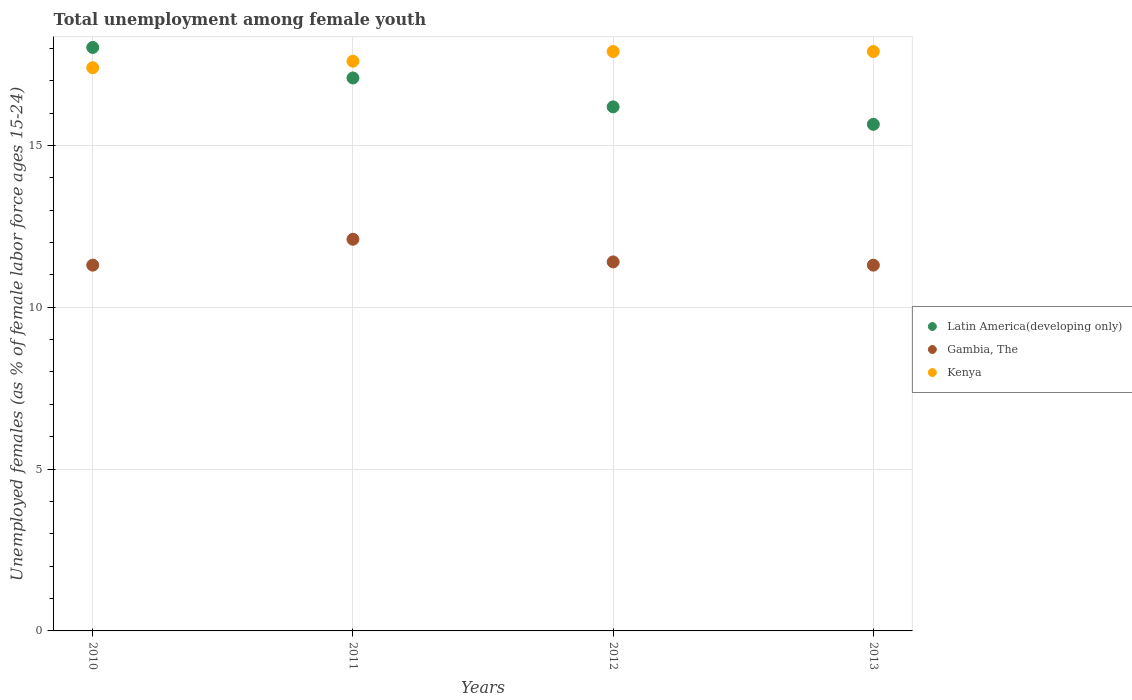Is the number of dotlines equal to the number of legend labels?
Provide a short and direct response. Yes. What is the percentage of unemployed females in in Gambia, The in 2010?
Your answer should be very brief. 11.3. Across all years, what is the maximum percentage of unemployed females in in Kenya?
Your answer should be compact. 17.9. Across all years, what is the minimum percentage of unemployed females in in Gambia, The?
Make the answer very short. 11.3. In which year was the percentage of unemployed females in in Gambia, The maximum?
Keep it short and to the point. 2011. What is the total percentage of unemployed females in in Kenya in the graph?
Give a very brief answer. 70.8. What is the difference between the percentage of unemployed females in in Gambia, The in 2010 and that in 2012?
Offer a terse response. -0.1. What is the difference between the percentage of unemployed females in in Gambia, The in 2013 and the percentage of unemployed females in in Latin America(developing only) in 2012?
Provide a short and direct response. -4.89. What is the average percentage of unemployed females in in Gambia, The per year?
Provide a short and direct response. 11.53. In the year 2010, what is the difference between the percentage of unemployed females in in Latin America(developing only) and percentage of unemployed females in in Gambia, The?
Your answer should be compact. 6.73. In how many years, is the percentage of unemployed females in in Kenya greater than 12 %?
Ensure brevity in your answer.  4. What is the ratio of the percentage of unemployed females in in Gambia, The in 2012 to that in 2013?
Give a very brief answer. 1.01. Is the difference between the percentage of unemployed females in in Latin America(developing only) in 2010 and 2012 greater than the difference between the percentage of unemployed females in in Gambia, The in 2010 and 2012?
Give a very brief answer. Yes. What is the difference between the highest and the second highest percentage of unemployed females in in Gambia, The?
Your answer should be compact. 0.7. What is the difference between the highest and the lowest percentage of unemployed females in in Latin America(developing only)?
Ensure brevity in your answer.  2.38. In how many years, is the percentage of unemployed females in in Gambia, The greater than the average percentage of unemployed females in in Gambia, The taken over all years?
Your response must be concise. 1. Is the sum of the percentage of unemployed females in in Gambia, The in 2012 and 2013 greater than the maximum percentage of unemployed females in in Kenya across all years?
Keep it short and to the point. Yes. Is it the case that in every year, the sum of the percentage of unemployed females in in Gambia, The and percentage of unemployed females in in Kenya  is greater than the percentage of unemployed females in in Latin America(developing only)?
Provide a short and direct response. Yes. Does the percentage of unemployed females in in Gambia, The monotonically increase over the years?
Ensure brevity in your answer.  No. How many years are there in the graph?
Provide a succinct answer. 4. Are the values on the major ticks of Y-axis written in scientific E-notation?
Offer a very short reply. No. Does the graph contain any zero values?
Give a very brief answer. No. Where does the legend appear in the graph?
Your answer should be very brief. Center right. How are the legend labels stacked?
Provide a succinct answer. Vertical. What is the title of the graph?
Your response must be concise. Total unemployment among female youth. What is the label or title of the X-axis?
Offer a terse response. Years. What is the label or title of the Y-axis?
Make the answer very short. Unemployed females (as % of female labor force ages 15-24). What is the Unemployed females (as % of female labor force ages 15-24) of Latin America(developing only) in 2010?
Offer a terse response. 18.03. What is the Unemployed females (as % of female labor force ages 15-24) of Gambia, The in 2010?
Provide a short and direct response. 11.3. What is the Unemployed females (as % of female labor force ages 15-24) in Kenya in 2010?
Provide a succinct answer. 17.4. What is the Unemployed females (as % of female labor force ages 15-24) in Latin America(developing only) in 2011?
Provide a short and direct response. 17.08. What is the Unemployed females (as % of female labor force ages 15-24) in Gambia, The in 2011?
Offer a terse response. 12.1. What is the Unemployed females (as % of female labor force ages 15-24) of Kenya in 2011?
Give a very brief answer. 17.6. What is the Unemployed females (as % of female labor force ages 15-24) in Latin America(developing only) in 2012?
Your answer should be compact. 16.19. What is the Unemployed females (as % of female labor force ages 15-24) of Gambia, The in 2012?
Your answer should be compact. 11.4. What is the Unemployed females (as % of female labor force ages 15-24) in Kenya in 2012?
Offer a very short reply. 17.9. What is the Unemployed females (as % of female labor force ages 15-24) of Latin America(developing only) in 2013?
Offer a very short reply. 15.65. What is the Unemployed females (as % of female labor force ages 15-24) in Gambia, The in 2013?
Keep it short and to the point. 11.3. What is the Unemployed females (as % of female labor force ages 15-24) in Kenya in 2013?
Offer a very short reply. 17.9. Across all years, what is the maximum Unemployed females (as % of female labor force ages 15-24) of Latin America(developing only)?
Make the answer very short. 18.03. Across all years, what is the maximum Unemployed females (as % of female labor force ages 15-24) in Gambia, The?
Keep it short and to the point. 12.1. Across all years, what is the maximum Unemployed females (as % of female labor force ages 15-24) of Kenya?
Keep it short and to the point. 17.9. Across all years, what is the minimum Unemployed females (as % of female labor force ages 15-24) in Latin America(developing only)?
Your answer should be very brief. 15.65. Across all years, what is the minimum Unemployed females (as % of female labor force ages 15-24) of Gambia, The?
Your response must be concise. 11.3. Across all years, what is the minimum Unemployed females (as % of female labor force ages 15-24) of Kenya?
Keep it short and to the point. 17.4. What is the total Unemployed females (as % of female labor force ages 15-24) of Latin America(developing only) in the graph?
Keep it short and to the point. 66.95. What is the total Unemployed females (as % of female labor force ages 15-24) of Gambia, The in the graph?
Offer a very short reply. 46.1. What is the total Unemployed females (as % of female labor force ages 15-24) in Kenya in the graph?
Your answer should be very brief. 70.8. What is the difference between the Unemployed females (as % of female labor force ages 15-24) of Latin America(developing only) in 2010 and that in 2011?
Offer a very short reply. 0.94. What is the difference between the Unemployed females (as % of female labor force ages 15-24) of Kenya in 2010 and that in 2011?
Offer a very short reply. -0.2. What is the difference between the Unemployed females (as % of female labor force ages 15-24) in Latin America(developing only) in 2010 and that in 2012?
Ensure brevity in your answer.  1.84. What is the difference between the Unemployed females (as % of female labor force ages 15-24) in Gambia, The in 2010 and that in 2012?
Your answer should be very brief. -0.1. What is the difference between the Unemployed females (as % of female labor force ages 15-24) of Kenya in 2010 and that in 2012?
Your response must be concise. -0.5. What is the difference between the Unemployed females (as % of female labor force ages 15-24) in Latin America(developing only) in 2010 and that in 2013?
Your answer should be very brief. 2.38. What is the difference between the Unemployed females (as % of female labor force ages 15-24) of Gambia, The in 2010 and that in 2013?
Keep it short and to the point. 0. What is the difference between the Unemployed females (as % of female labor force ages 15-24) of Kenya in 2010 and that in 2013?
Provide a short and direct response. -0.5. What is the difference between the Unemployed females (as % of female labor force ages 15-24) of Latin America(developing only) in 2011 and that in 2012?
Your answer should be compact. 0.89. What is the difference between the Unemployed females (as % of female labor force ages 15-24) of Latin America(developing only) in 2011 and that in 2013?
Provide a short and direct response. 1.43. What is the difference between the Unemployed females (as % of female labor force ages 15-24) of Kenya in 2011 and that in 2013?
Your response must be concise. -0.3. What is the difference between the Unemployed females (as % of female labor force ages 15-24) of Latin America(developing only) in 2012 and that in 2013?
Your answer should be compact. 0.54. What is the difference between the Unemployed females (as % of female labor force ages 15-24) in Latin America(developing only) in 2010 and the Unemployed females (as % of female labor force ages 15-24) in Gambia, The in 2011?
Your answer should be very brief. 5.93. What is the difference between the Unemployed females (as % of female labor force ages 15-24) in Latin America(developing only) in 2010 and the Unemployed females (as % of female labor force ages 15-24) in Kenya in 2011?
Offer a very short reply. 0.43. What is the difference between the Unemployed females (as % of female labor force ages 15-24) of Latin America(developing only) in 2010 and the Unemployed females (as % of female labor force ages 15-24) of Gambia, The in 2012?
Your answer should be compact. 6.63. What is the difference between the Unemployed females (as % of female labor force ages 15-24) in Latin America(developing only) in 2010 and the Unemployed females (as % of female labor force ages 15-24) in Kenya in 2012?
Provide a short and direct response. 0.13. What is the difference between the Unemployed females (as % of female labor force ages 15-24) of Gambia, The in 2010 and the Unemployed females (as % of female labor force ages 15-24) of Kenya in 2012?
Ensure brevity in your answer.  -6.6. What is the difference between the Unemployed females (as % of female labor force ages 15-24) of Latin America(developing only) in 2010 and the Unemployed females (as % of female labor force ages 15-24) of Gambia, The in 2013?
Provide a short and direct response. 6.73. What is the difference between the Unemployed females (as % of female labor force ages 15-24) of Latin America(developing only) in 2010 and the Unemployed females (as % of female labor force ages 15-24) of Kenya in 2013?
Provide a succinct answer. 0.13. What is the difference between the Unemployed females (as % of female labor force ages 15-24) of Latin America(developing only) in 2011 and the Unemployed females (as % of female labor force ages 15-24) of Gambia, The in 2012?
Your answer should be compact. 5.68. What is the difference between the Unemployed females (as % of female labor force ages 15-24) in Latin America(developing only) in 2011 and the Unemployed females (as % of female labor force ages 15-24) in Kenya in 2012?
Provide a succinct answer. -0.82. What is the difference between the Unemployed females (as % of female labor force ages 15-24) in Latin America(developing only) in 2011 and the Unemployed females (as % of female labor force ages 15-24) in Gambia, The in 2013?
Offer a very short reply. 5.78. What is the difference between the Unemployed females (as % of female labor force ages 15-24) in Latin America(developing only) in 2011 and the Unemployed females (as % of female labor force ages 15-24) in Kenya in 2013?
Offer a terse response. -0.82. What is the difference between the Unemployed females (as % of female labor force ages 15-24) in Gambia, The in 2011 and the Unemployed females (as % of female labor force ages 15-24) in Kenya in 2013?
Your response must be concise. -5.8. What is the difference between the Unemployed females (as % of female labor force ages 15-24) in Latin America(developing only) in 2012 and the Unemployed females (as % of female labor force ages 15-24) in Gambia, The in 2013?
Ensure brevity in your answer.  4.89. What is the difference between the Unemployed females (as % of female labor force ages 15-24) in Latin America(developing only) in 2012 and the Unemployed females (as % of female labor force ages 15-24) in Kenya in 2013?
Make the answer very short. -1.71. What is the difference between the Unemployed females (as % of female labor force ages 15-24) of Gambia, The in 2012 and the Unemployed females (as % of female labor force ages 15-24) of Kenya in 2013?
Offer a very short reply. -6.5. What is the average Unemployed females (as % of female labor force ages 15-24) of Latin America(developing only) per year?
Give a very brief answer. 16.74. What is the average Unemployed females (as % of female labor force ages 15-24) in Gambia, The per year?
Provide a short and direct response. 11.53. What is the average Unemployed females (as % of female labor force ages 15-24) in Kenya per year?
Keep it short and to the point. 17.7. In the year 2010, what is the difference between the Unemployed females (as % of female labor force ages 15-24) of Latin America(developing only) and Unemployed females (as % of female labor force ages 15-24) of Gambia, The?
Give a very brief answer. 6.73. In the year 2010, what is the difference between the Unemployed females (as % of female labor force ages 15-24) in Latin America(developing only) and Unemployed females (as % of female labor force ages 15-24) in Kenya?
Your answer should be very brief. 0.63. In the year 2011, what is the difference between the Unemployed females (as % of female labor force ages 15-24) in Latin America(developing only) and Unemployed females (as % of female labor force ages 15-24) in Gambia, The?
Provide a succinct answer. 4.98. In the year 2011, what is the difference between the Unemployed females (as % of female labor force ages 15-24) of Latin America(developing only) and Unemployed females (as % of female labor force ages 15-24) of Kenya?
Offer a very short reply. -0.52. In the year 2011, what is the difference between the Unemployed females (as % of female labor force ages 15-24) in Gambia, The and Unemployed females (as % of female labor force ages 15-24) in Kenya?
Keep it short and to the point. -5.5. In the year 2012, what is the difference between the Unemployed females (as % of female labor force ages 15-24) in Latin America(developing only) and Unemployed females (as % of female labor force ages 15-24) in Gambia, The?
Your answer should be compact. 4.79. In the year 2012, what is the difference between the Unemployed females (as % of female labor force ages 15-24) in Latin America(developing only) and Unemployed females (as % of female labor force ages 15-24) in Kenya?
Make the answer very short. -1.71. In the year 2012, what is the difference between the Unemployed females (as % of female labor force ages 15-24) in Gambia, The and Unemployed females (as % of female labor force ages 15-24) in Kenya?
Provide a short and direct response. -6.5. In the year 2013, what is the difference between the Unemployed females (as % of female labor force ages 15-24) in Latin America(developing only) and Unemployed females (as % of female labor force ages 15-24) in Gambia, The?
Keep it short and to the point. 4.35. In the year 2013, what is the difference between the Unemployed females (as % of female labor force ages 15-24) in Latin America(developing only) and Unemployed females (as % of female labor force ages 15-24) in Kenya?
Your answer should be very brief. -2.25. In the year 2013, what is the difference between the Unemployed females (as % of female labor force ages 15-24) in Gambia, The and Unemployed females (as % of female labor force ages 15-24) in Kenya?
Offer a terse response. -6.6. What is the ratio of the Unemployed females (as % of female labor force ages 15-24) of Latin America(developing only) in 2010 to that in 2011?
Offer a terse response. 1.06. What is the ratio of the Unemployed females (as % of female labor force ages 15-24) of Gambia, The in 2010 to that in 2011?
Provide a short and direct response. 0.93. What is the ratio of the Unemployed females (as % of female labor force ages 15-24) of Latin America(developing only) in 2010 to that in 2012?
Offer a very short reply. 1.11. What is the ratio of the Unemployed females (as % of female labor force ages 15-24) in Gambia, The in 2010 to that in 2012?
Offer a very short reply. 0.99. What is the ratio of the Unemployed females (as % of female labor force ages 15-24) in Kenya in 2010 to that in 2012?
Ensure brevity in your answer.  0.97. What is the ratio of the Unemployed females (as % of female labor force ages 15-24) of Latin America(developing only) in 2010 to that in 2013?
Ensure brevity in your answer.  1.15. What is the ratio of the Unemployed females (as % of female labor force ages 15-24) in Gambia, The in 2010 to that in 2013?
Make the answer very short. 1. What is the ratio of the Unemployed females (as % of female labor force ages 15-24) in Kenya in 2010 to that in 2013?
Your answer should be compact. 0.97. What is the ratio of the Unemployed females (as % of female labor force ages 15-24) in Latin America(developing only) in 2011 to that in 2012?
Keep it short and to the point. 1.06. What is the ratio of the Unemployed females (as % of female labor force ages 15-24) of Gambia, The in 2011 to that in 2012?
Ensure brevity in your answer.  1.06. What is the ratio of the Unemployed females (as % of female labor force ages 15-24) in Kenya in 2011 to that in 2012?
Your response must be concise. 0.98. What is the ratio of the Unemployed females (as % of female labor force ages 15-24) of Latin America(developing only) in 2011 to that in 2013?
Provide a succinct answer. 1.09. What is the ratio of the Unemployed females (as % of female labor force ages 15-24) of Gambia, The in 2011 to that in 2013?
Your answer should be very brief. 1.07. What is the ratio of the Unemployed females (as % of female labor force ages 15-24) of Kenya in 2011 to that in 2013?
Your response must be concise. 0.98. What is the ratio of the Unemployed females (as % of female labor force ages 15-24) of Latin America(developing only) in 2012 to that in 2013?
Make the answer very short. 1.03. What is the ratio of the Unemployed females (as % of female labor force ages 15-24) of Gambia, The in 2012 to that in 2013?
Make the answer very short. 1.01. What is the ratio of the Unemployed females (as % of female labor force ages 15-24) of Kenya in 2012 to that in 2013?
Provide a short and direct response. 1. What is the difference between the highest and the second highest Unemployed females (as % of female labor force ages 15-24) of Latin America(developing only)?
Provide a succinct answer. 0.94. What is the difference between the highest and the lowest Unemployed females (as % of female labor force ages 15-24) of Latin America(developing only)?
Your answer should be very brief. 2.38. What is the difference between the highest and the lowest Unemployed females (as % of female labor force ages 15-24) of Gambia, The?
Provide a short and direct response. 0.8. What is the difference between the highest and the lowest Unemployed females (as % of female labor force ages 15-24) in Kenya?
Offer a terse response. 0.5. 